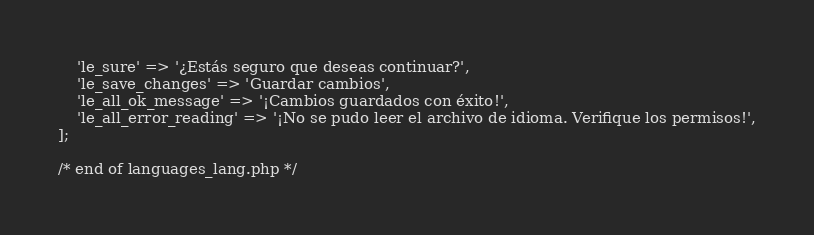<code> <loc_0><loc_0><loc_500><loc_500><_PHP_>    'le_sure' => '¿Estás seguro que deseas continuar?',
    'le_save_changes' => 'Guardar cambios',
    'le_all_ok_message' => '¡Cambios guardados con éxito!',
    'le_all_error_reading' => '¡No se pudo leer el archivo de idioma. Verifique los permisos!',
];

/* end of languages_lang.php */
</code> 